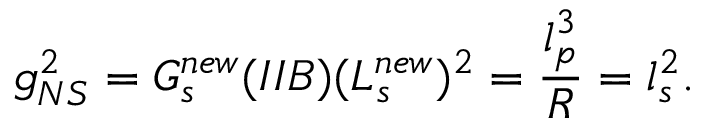Convert formula to latex. <formula><loc_0><loc_0><loc_500><loc_500>g _ { N S } ^ { 2 } = G _ { s } ^ { n e w } ( I I B ) ( L _ { s } ^ { n e w } ) ^ { 2 } = \frac { l _ { p } ^ { 3 } } { R } = l _ { s } ^ { 2 } .</formula> 